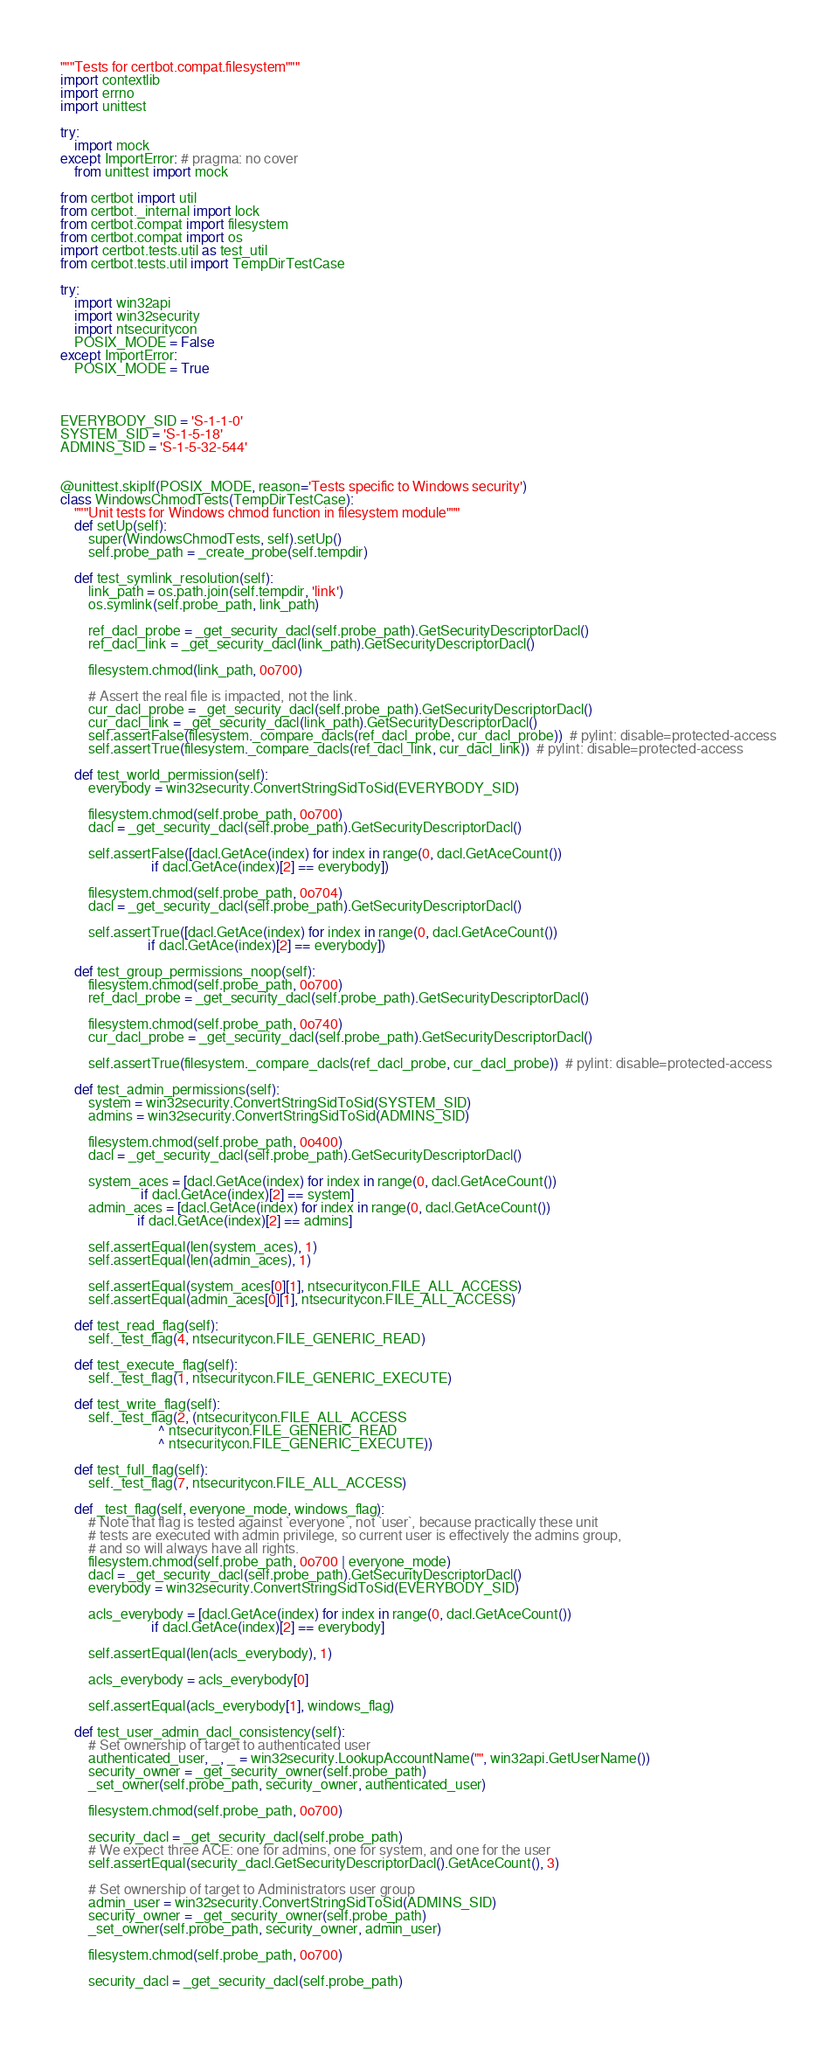<code> <loc_0><loc_0><loc_500><loc_500><_Python_>"""Tests for certbot.compat.filesystem"""
import contextlib
import errno
import unittest

try:
    import mock
except ImportError: # pragma: no cover
    from unittest import mock

from certbot import util
from certbot._internal import lock
from certbot.compat import filesystem
from certbot.compat import os
import certbot.tests.util as test_util
from certbot.tests.util import TempDirTestCase

try:
    import win32api
    import win32security
    import ntsecuritycon
    POSIX_MODE = False
except ImportError:
    POSIX_MODE = True



EVERYBODY_SID = 'S-1-1-0'
SYSTEM_SID = 'S-1-5-18'
ADMINS_SID = 'S-1-5-32-544'


@unittest.skipIf(POSIX_MODE, reason='Tests specific to Windows security')
class WindowsChmodTests(TempDirTestCase):
    """Unit tests for Windows chmod function in filesystem module"""
    def setUp(self):
        super(WindowsChmodTests, self).setUp()
        self.probe_path = _create_probe(self.tempdir)

    def test_symlink_resolution(self):
        link_path = os.path.join(self.tempdir, 'link')
        os.symlink(self.probe_path, link_path)

        ref_dacl_probe = _get_security_dacl(self.probe_path).GetSecurityDescriptorDacl()
        ref_dacl_link = _get_security_dacl(link_path).GetSecurityDescriptorDacl()

        filesystem.chmod(link_path, 0o700)

        # Assert the real file is impacted, not the link.
        cur_dacl_probe = _get_security_dacl(self.probe_path).GetSecurityDescriptorDacl()
        cur_dacl_link = _get_security_dacl(link_path).GetSecurityDescriptorDacl()
        self.assertFalse(filesystem._compare_dacls(ref_dacl_probe, cur_dacl_probe))  # pylint: disable=protected-access
        self.assertTrue(filesystem._compare_dacls(ref_dacl_link, cur_dacl_link))  # pylint: disable=protected-access

    def test_world_permission(self):
        everybody = win32security.ConvertStringSidToSid(EVERYBODY_SID)

        filesystem.chmod(self.probe_path, 0o700)
        dacl = _get_security_dacl(self.probe_path).GetSecurityDescriptorDacl()

        self.assertFalse([dacl.GetAce(index) for index in range(0, dacl.GetAceCount())
                          if dacl.GetAce(index)[2] == everybody])

        filesystem.chmod(self.probe_path, 0o704)
        dacl = _get_security_dacl(self.probe_path).GetSecurityDescriptorDacl()

        self.assertTrue([dacl.GetAce(index) for index in range(0, dacl.GetAceCount())
                         if dacl.GetAce(index)[2] == everybody])

    def test_group_permissions_noop(self):
        filesystem.chmod(self.probe_path, 0o700)
        ref_dacl_probe = _get_security_dacl(self.probe_path).GetSecurityDescriptorDacl()

        filesystem.chmod(self.probe_path, 0o740)
        cur_dacl_probe = _get_security_dacl(self.probe_path).GetSecurityDescriptorDacl()

        self.assertTrue(filesystem._compare_dacls(ref_dacl_probe, cur_dacl_probe))  # pylint: disable=protected-access

    def test_admin_permissions(self):
        system = win32security.ConvertStringSidToSid(SYSTEM_SID)
        admins = win32security.ConvertStringSidToSid(ADMINS_SID)

        filesystem.chmod(self.probe_path, 0o400)
        dacl = _get_security_dacl(self.probe_path).GetSecurityDescriptorDacl()

        system_aces = [dacl.GetAce(index) for index in range(0, dacl.GetAceCount())
                       if dacl.GetAce(index)[2] == system]
        admin_aces = [dacl.GetAce(index) for index in range(0, dacl.GetAceCount())
                      if dacl.GetAce(index)[2] == admins]

        self.assertEqual(len(system_aces), 1)
        self.assertEqual(len(admin_aces), 1)

        self.assertEqual(system_aces[0][1], ntsecuritycon.FILE_ALL_ACCESS)
        self.assertEqual(admin_aces[0][1], ntsecuritycon.FILE_ALL_ACCESS)

    def test_read_flag(self):
        self._test_flag(4, ntsecuritycon.FILE_GENERIC_READ)

    def test_execute_flag(self):
        self._test_flag(1, ntsecuritycon.FILE_GENERIC_EXECUTE)

    def test_write_flag(self):
        self._test_flag(2, (ntsecuritycon.FILE_ALL_ACCESS
                            ^ ntsecuritycon.FILE_GENERIC_READ
                            ^ ntsecuritycon.FILE_GENERIC_EXECUTE))

    def test_full_flag(self):
        self._test_flag(7, ntsecuritycon.FILE_ALL_ACCESS)

    def _test_flag(self, everyone_mode, windows_flag):
        # Note that flag is tested against `everyone`, not `user`, because practically these unit
        # tests are executed with admin privilege, so current user is effectively the admins group,
        # and so will always have all rights.
        filesystem.chmod(self.probe_path, 0o700 | everyone_mode)
        dacl = _get_security_dacl(self.probe_path).GetSecurityDescriptorDacl()
        everybody = win32security.ConvertStringSidToSid(EVERYBODY_SID)

        acls_everybody = [dacl.GetAce(index) for index in range(0, dacl.GetAceCount())
                          if dacl.GetAce(index)[2] == everybody]

        self.assertEqual(len(acls_everybody), 1)

        acls_everybody = acls_everybody[0]

        self.assertEqual(acls_everybody[1], windows_flag)

    def test_user_admin_dacl_consistency(self):
        # Set ownership of target to authenticated user
        authenticated_user, _, _ = win32security.LookupAccountName("", win32api.GetUserName())
        security_owner = _get_security_owner(self.probe_path)
        _set_owner(self.probe_path, security_owner, authenticated_user)

        filesystem.chmod(self.probe_path, 0o700)

        security_dacl = _get_security_dacl(self.probe_path)
        # We expect three ACE: one for admins, one for system, and one for the user
        self.assertEqual(security_dacl.GetSecurityDescriptorDacl().GetAceCount(), 3)

        # Set ownership of target to Administrators user group
        admin_user = win32security.ConvertStringSidToSid(ADMINS_SID)
        security_owner = _get_security_owner(self.probe_path)
        _set_owner(self.probe_path, security_owner, admin_user)

        filesystem.chmod(self.probe_path, 0o700)

        security_dacl = _get_security_dacl(self.probe_path)</code> 